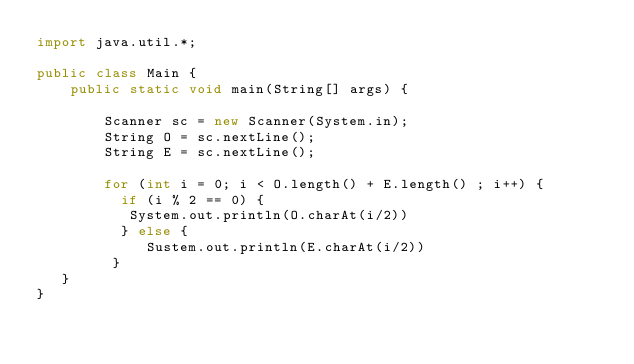<code> <loc_0><loc_0><loc_500><loc_500><_Java_>import java.util.*;

public class Main {
    public static void main(String[] args) {

        Scanner sc = new Scanner(System.in);
        String O = sc.nextLine();
        String E = sc.nextLine();
        
        for (int i = 0; i < O.length() + E.length() ; i++) {
          if (i % 2 == 0) {
           System.out.println(O.charAt(i/2))
          } else {
             Sustem.out.println(E.charAt(i/2))
         }
   }
}</code> 